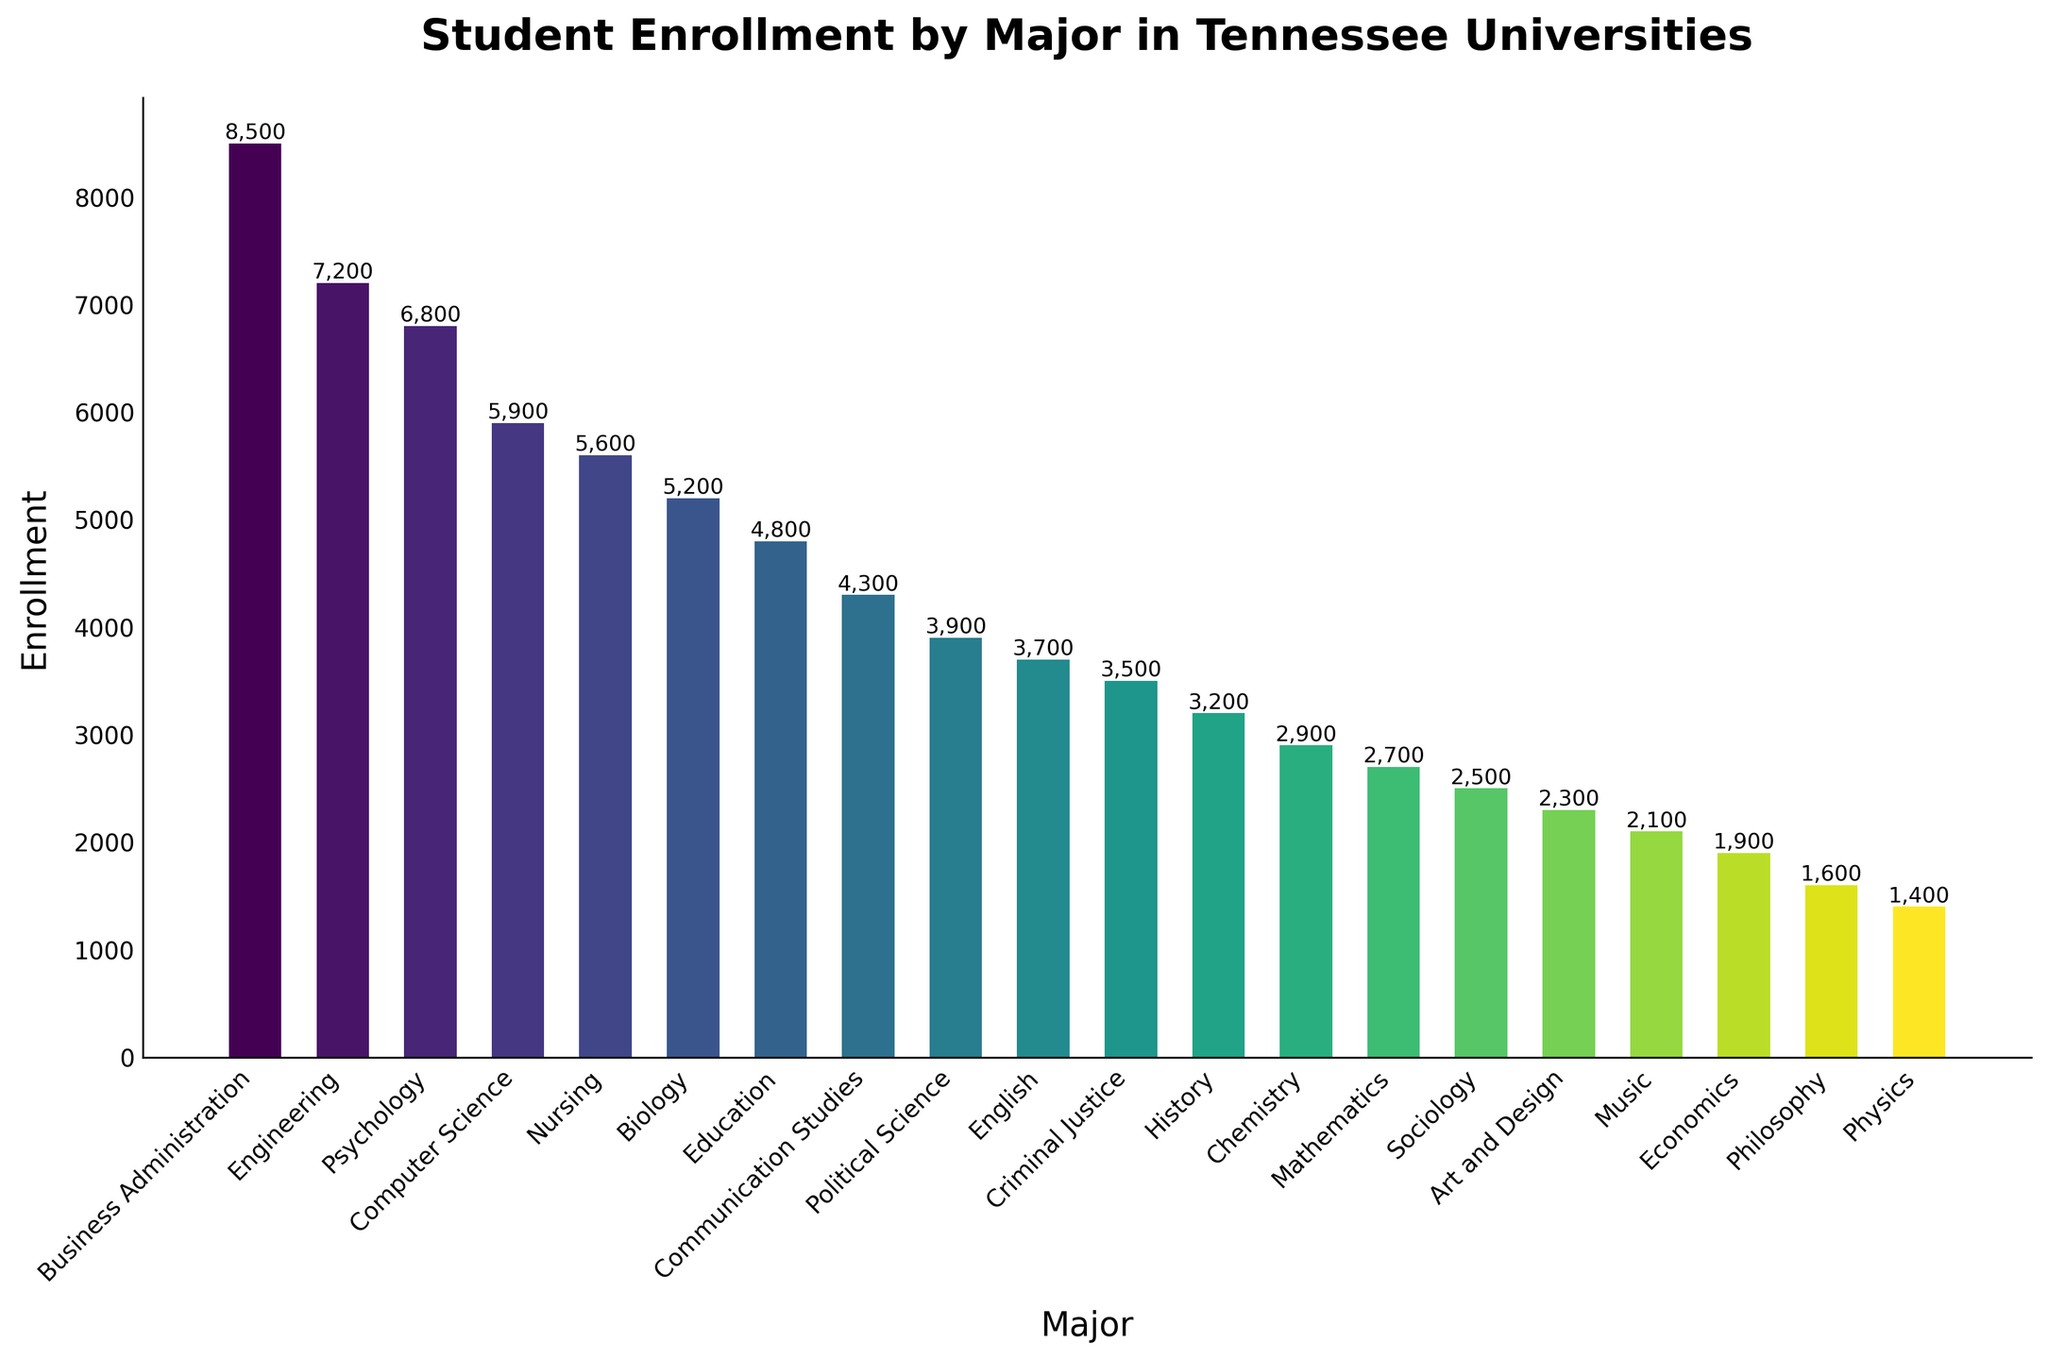Which major has the highest enrollment? The bar with the greatest height represents the major with the highest enrollment, which is Business Administration.
Answer: Business Administration Which major has the lowest enrollment? The bar with the smallest height represents the major with the lowest enrollment, which is Physics.
Answer: Physics How many more students are enrolled in Engineering compared to Nursing? Identify the enrollment for both majors (Engineering: 7200, Nursing: 5600), then subtract the smaller number from the larger number (7200 - 5600).
Answer: 1600 What is the total enrollment for Psychology, Computer Science, and Nursing? Identify the enrollment for each major (Psychology: 6800, Computer Science: 5900, Nursing: 5600), then sum them up (6800 + 5900 + 5600).
Answer: 18,200 Which major has higher enrollment, History or Philosophy? Compare the heights of the bars representing History (3200) and Philosophy (1600).
Answer: History What is the average enrollment of the top three majors? Identify the enrollment for the top three majors (Business Administration: 8500, Engineering: 7200, Psychology: 6800), sum them up (8500 + 7200 + 6800), and divide by 3.
Answer: 7,500 How many more students are enrolled in Communication Studies compared to Economics? Identify the enrollment for both majors (Communication Studies: 4300, Economics: 1900), then subtract the smaller number from the larger number (4300 - 1900).
Answer: 2400 Is the enrollment in Computer Science greater than that in Education and Communication Studies combined? Sum the enrollment for Education (4800) and Communication Studies (4300), which is 9100. Compare this sum with the enrollment for Computer Science (5900).
Answer: No Which major between Chemistry and Sociology has the larger enrollment? Compare the heights of the bars representing Chemistry (2900) and Sociology (2500).
Answer: Chemistry What is the combined enrollment of the three lowest enrolled majors? Identify the enrollment for the three lowest majors (Physics: 1400, Philosophy: 1600, Economics: 1900), sum them up (1400 + 1600 + 1900).
Answer: 4900 